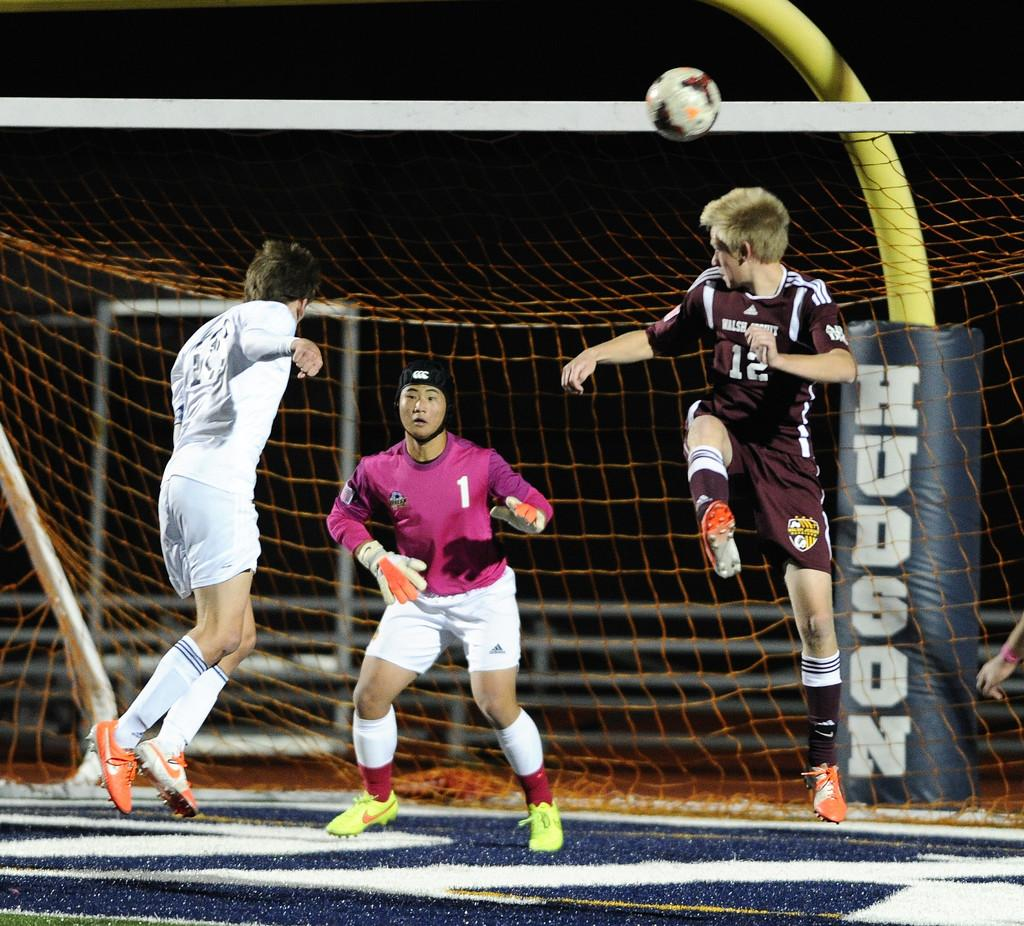<image>
Share a concise interpretation of the image provided. a soccer game with a goalie inside of the net with brand of the net called Hudson. 